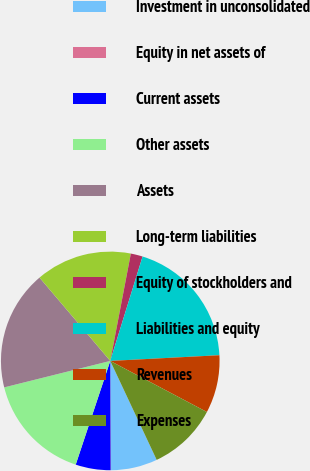<chart> <loc_0><loc_0><loc_500><loc_500><pie_chart><fcel>Investment in unconsolidated<fcel>Equity in net assets of<fcel>Current assets<fcel>Other assets<fcel>Assets<fcel>Long-term liabilities<fcel>Equity of stockholders and<fcel>Liabilities and equity<fcel>Revenues<fcel>Expenses<nl><fcel>6.87%<fcel>0.06%<fcel>5.17%<fcel>15.99%<fcel>17.69%<fcel>14.22%<fcel>1.76%<fcel>19.39%<fcel>8.57%<fcel>10.28%<nl></chart> 